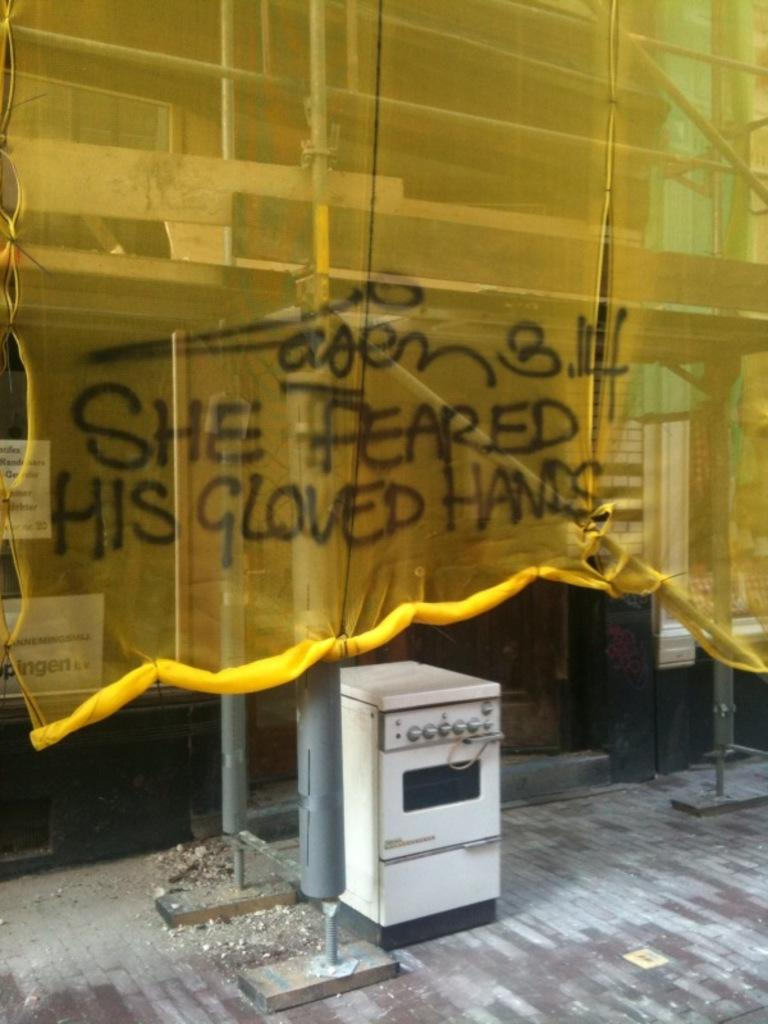<image>
Render a clear and concise summary of the photo. A yellow curtain has been spray painted to say she feared his gloved hands. 